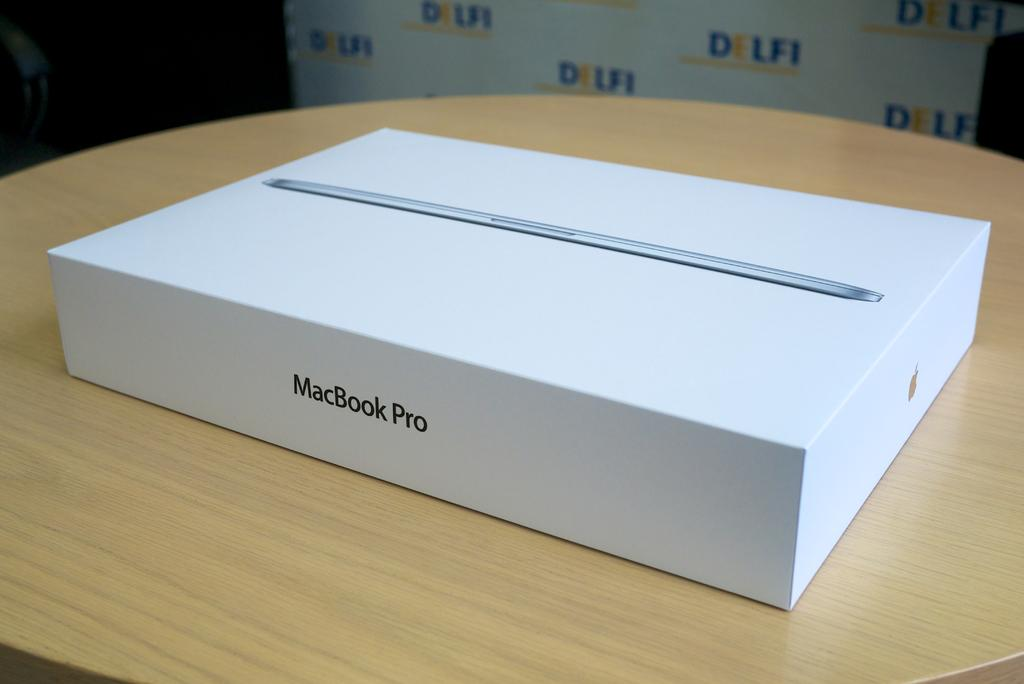<image>
Share a concise interpretation of the image provided. A white box that contains a MacBook Pro. 